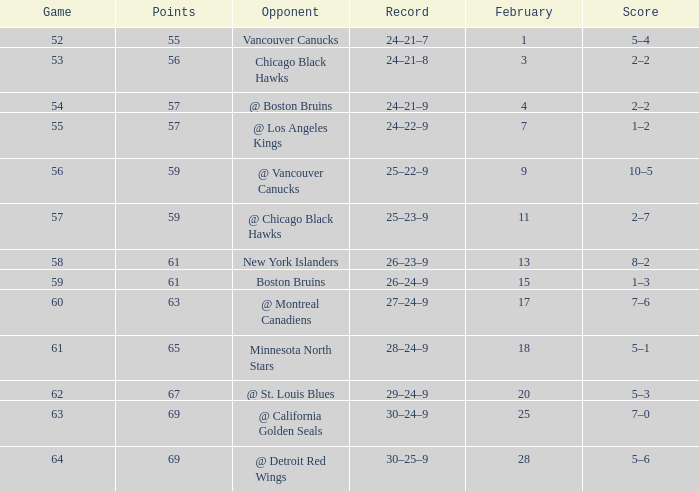Which opponent has a game larger than 61, february smaller than 28, and fewer points than 69? @ St. Louis Blues. 